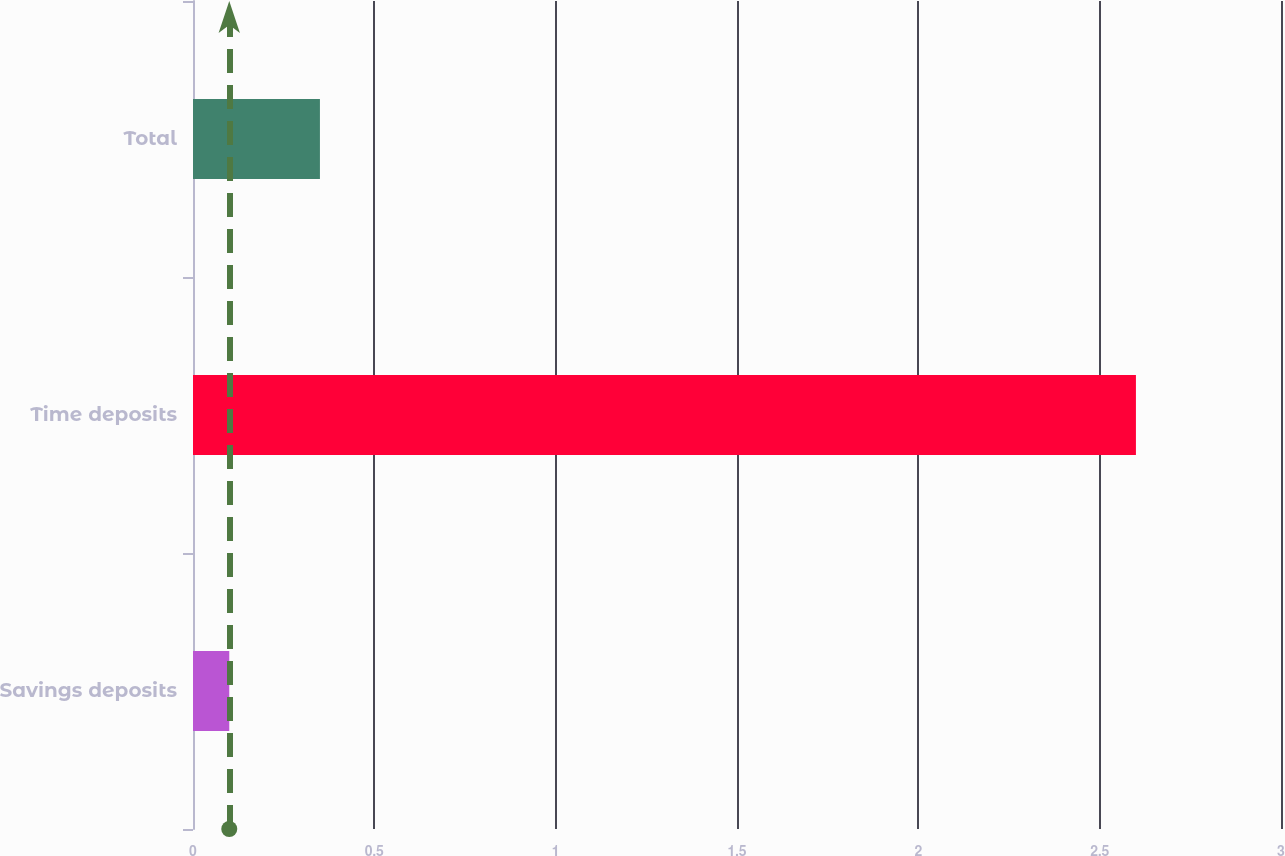<chart> <loc_0><loc_0><loc_500><loc_500><bar_chart><fcel>Savings deposits<fcel>Time deposits<fcel>Total<nl><fcel>0.1<fcel>2.6<fcel>0.35<nl></chart> 